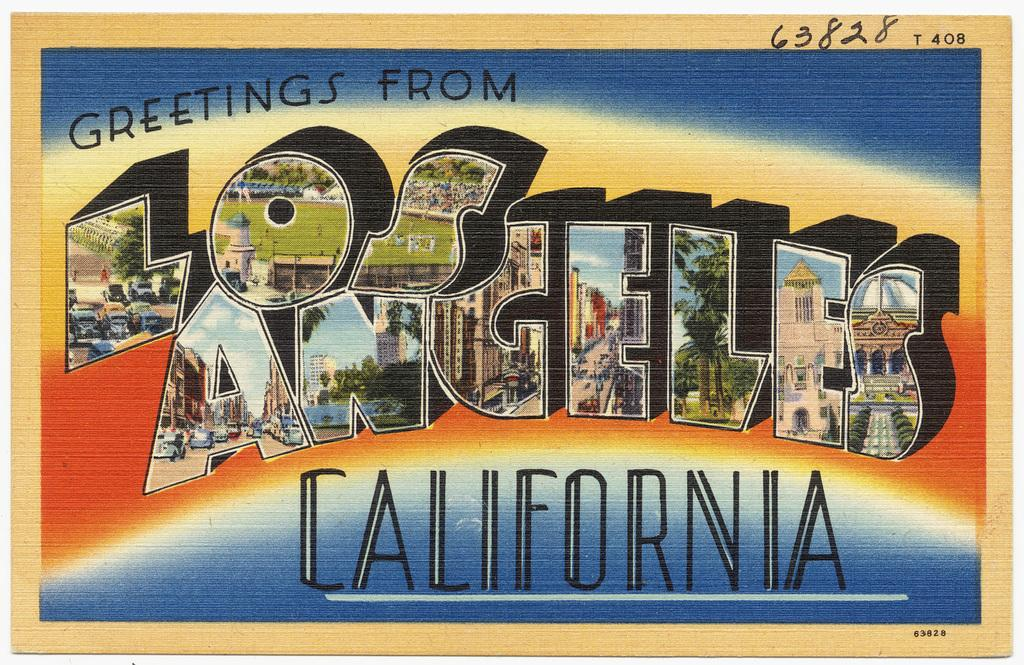<image>
Summarize the visual content of the image. A post card that says greetings from Los Angeles California. 